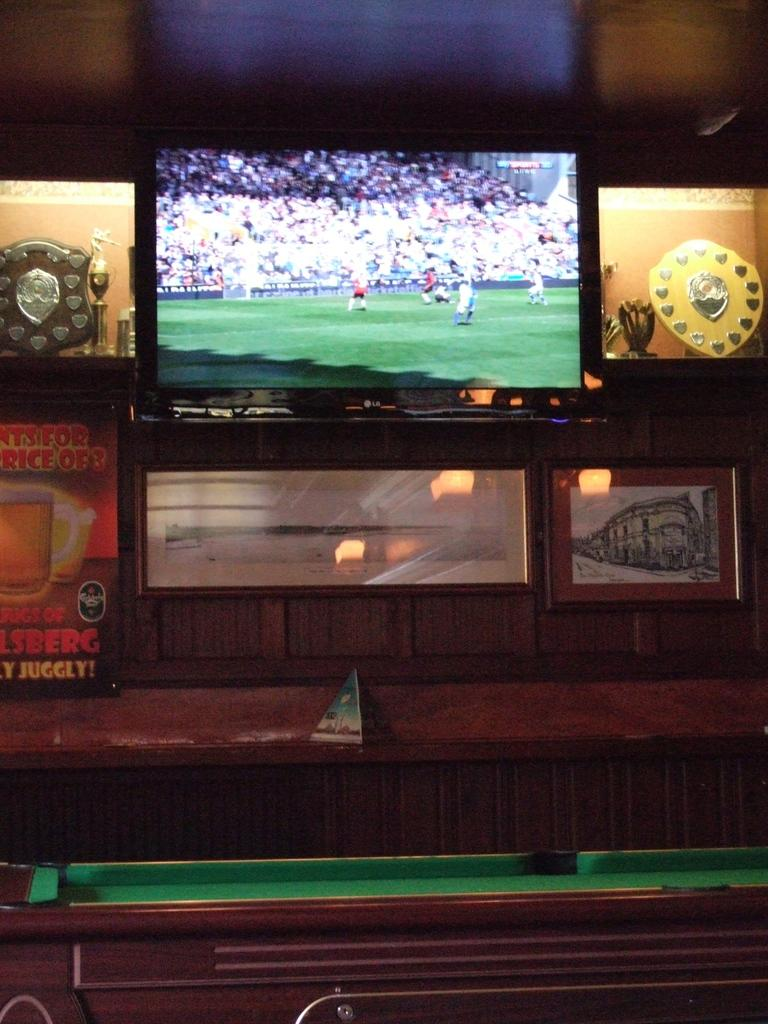What electronic device is present in the image? There is a television in the image. What type of items can be seen that represent achievements? There are awards in the image. What is in the glass that is visible in the image? There is a drink in the glass in the image. What type of game is being played or displayed in the image? There is a snooker board in the image. What type of mountain can be seen in the background of the image? There is no mountain present in the image. What angle is the ice being served at in the image? There is no ice or serving of ice present in the image. 